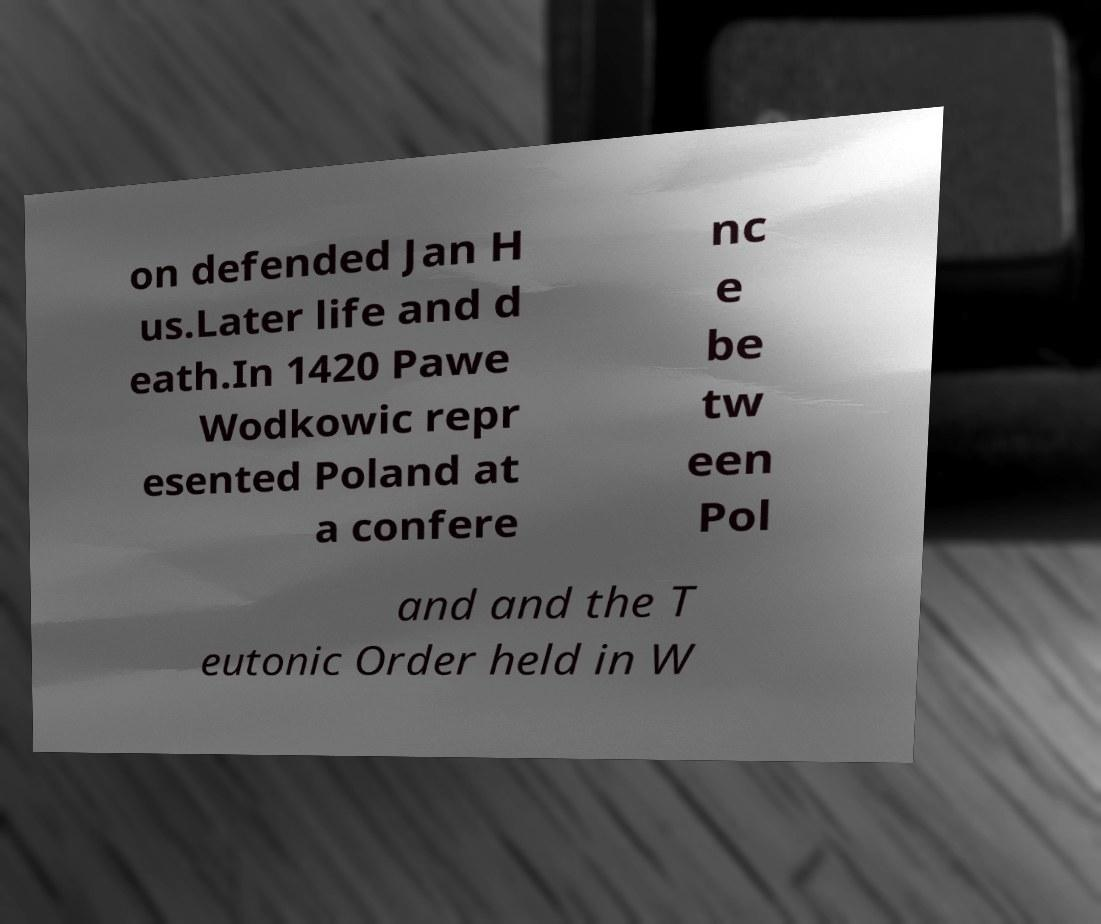There's text embedded in this image that I need extracted. Can you transcribe it verbatim? on defended Jan H us.Later life and d eath.In 1420 Pawe Wodkowic repr esented Poland at a confere nc e be tw een Pol and and the T eutonic Order held in W 